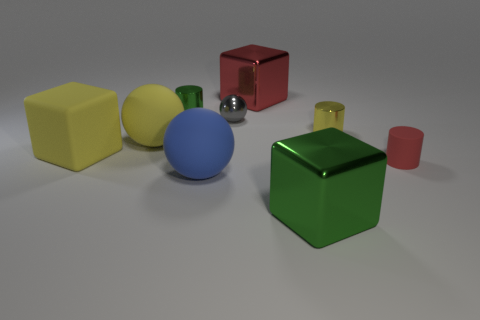There is an object that is behind the small green object; what is its shape? The object located behind the small green object is a cube. It has a distinguished red color and reflects a glossy surface, which implies a smooth texture. 